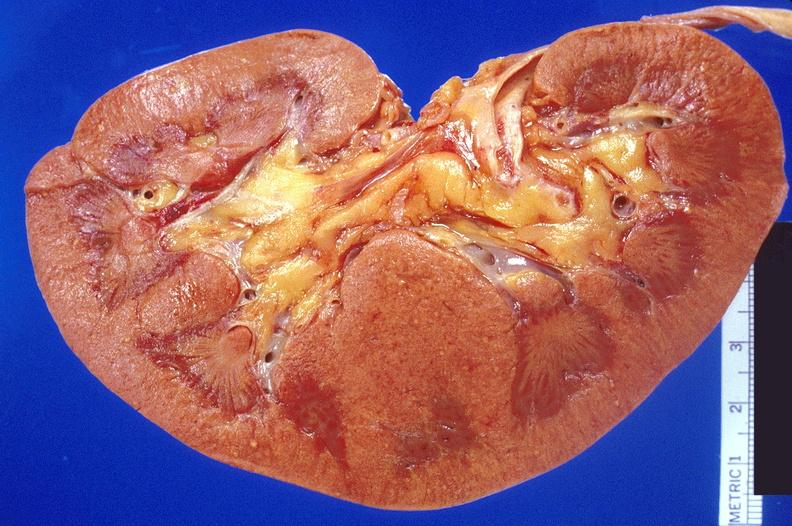does this image show kidney, candida abscesses?
Answer the question using a single word or phrase. Yes 